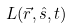Convert formula to latex. <formula><loc_0><loc_0><loc_500><loc_500>L ( \vec { r } , \hat { s } , t )</formula> 